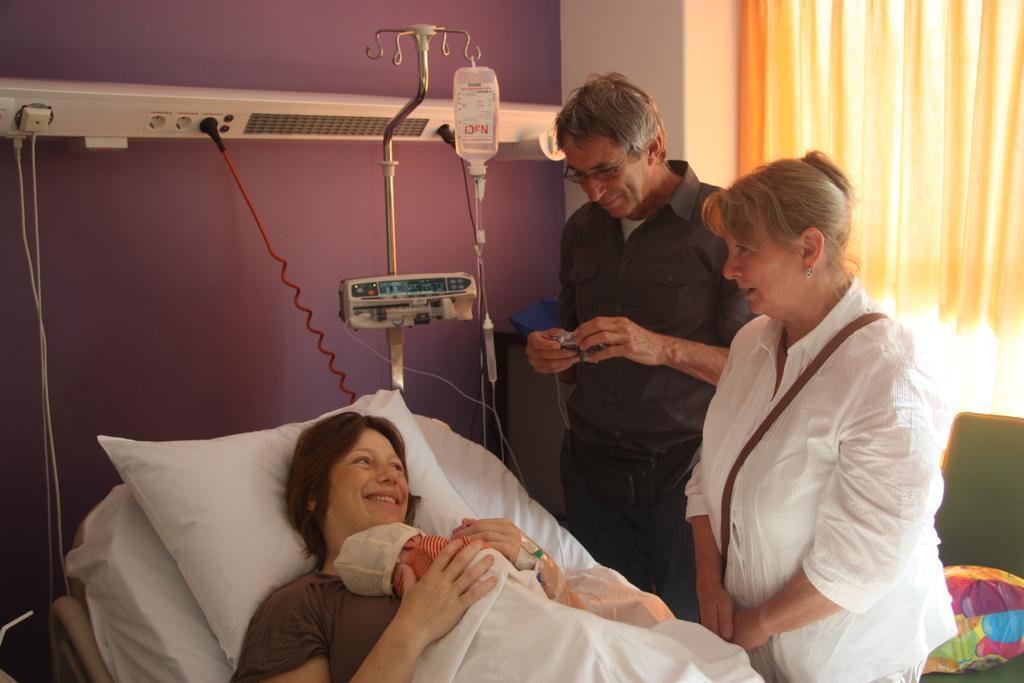Can you describe this image briefly? At the bottom of the image a woman is laying and holding a baby in her hands. Left side there is a woman standing with a wearing a white shirt, behind there is a person standing. Beside the bed there is a stand hanging with a saline bottle. To the wall there is a plug board attached to it. At right side there is a curtain and a chair with a bag on it. 